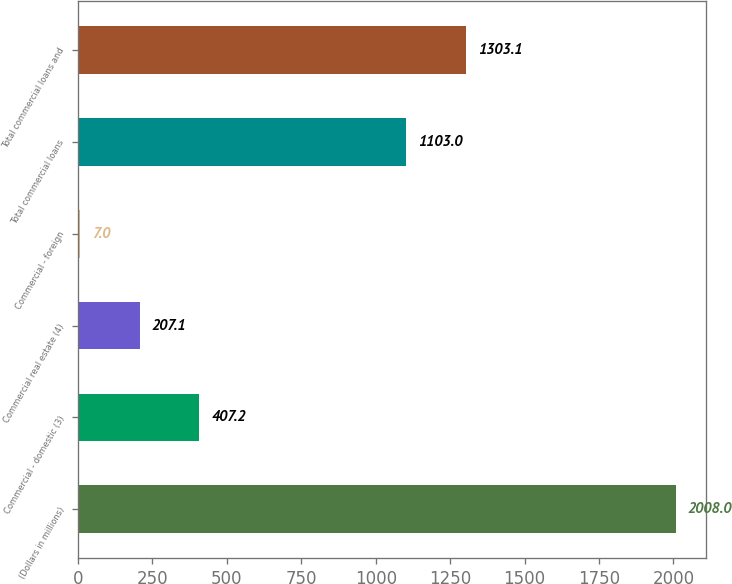<chart> <loc_0><loc_0><loc_500><loc_500><bar_chart><fcel>(Dollars in millions)<fcel>Commercial - domestic (3)<fcel>Commercial real estate (4)<fcel>Commercial - foreign<fcel>Total commercial loans<fcel>Total commercial loans and<nl><fcel>2008<fcel>407.2<fcel>207.1<fcel>7<fcel>1103<fcel>1303.1<nl></chart> 